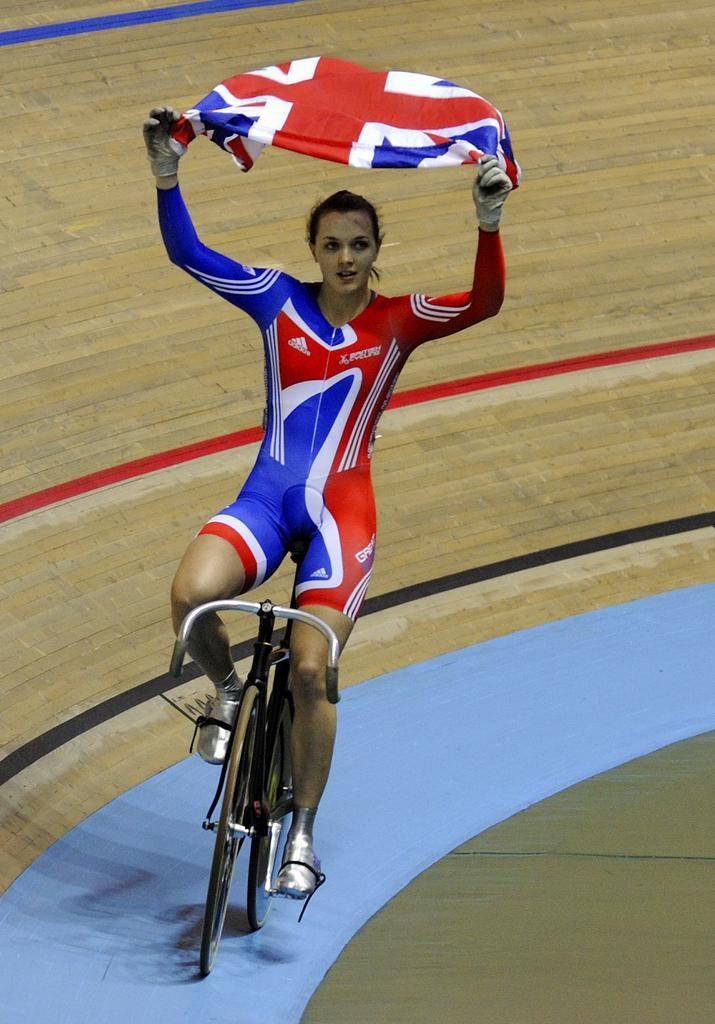How would you summarize this image in a sentence or two? In this image I can see a person is on the bicycle. The person is wearing red and blue dress and she is holding flag. Back I can see a board. 